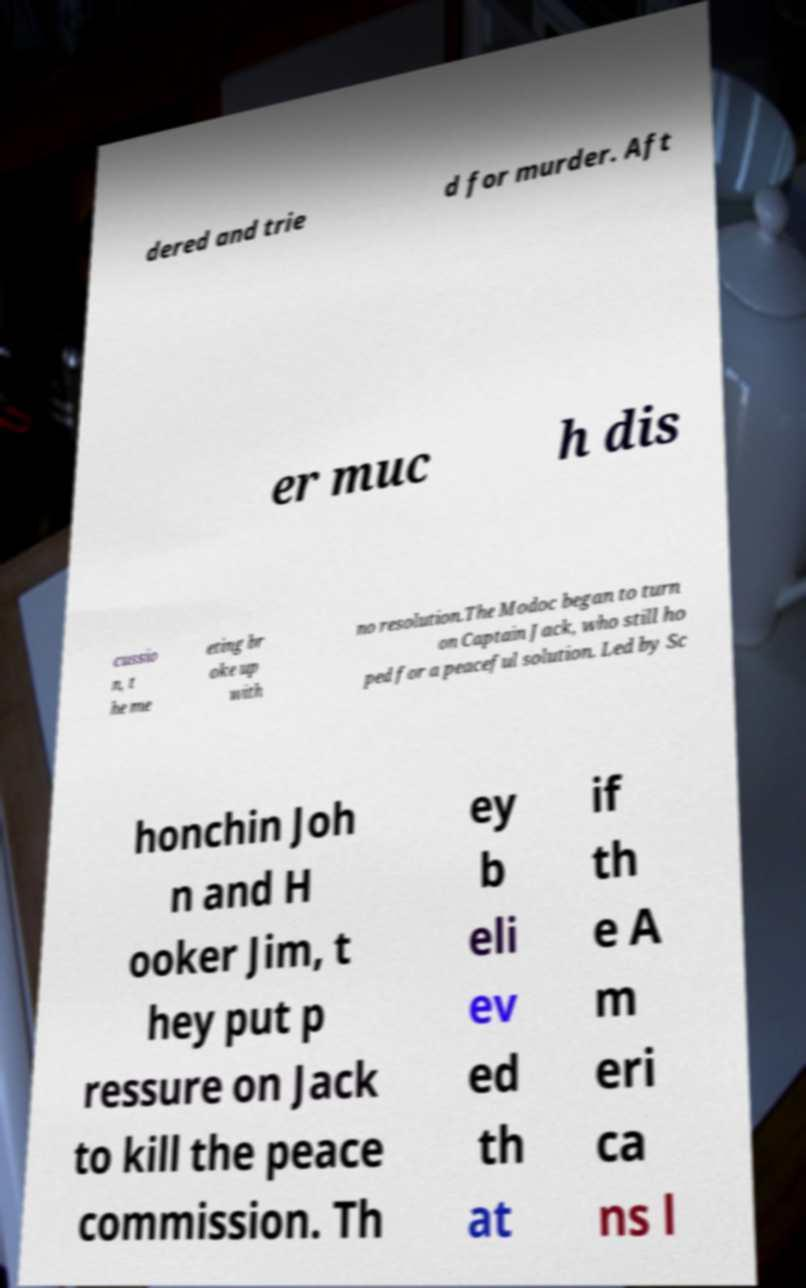Can you accurately transcribe the text from the provided image for me? dered and trie d for murder. Aft er muc h dis cussio n, t he me eting br oke up with no resolution.The Modoc began to turn on Captain Jack, who still ho ped for a peaceful solution. Led by Sc honchin Joh n and H ooker Jim, t hey put p ressure on Jack to kill the peace commission. Th ey b eli ev ed th at if th e A m eri ca ns l 